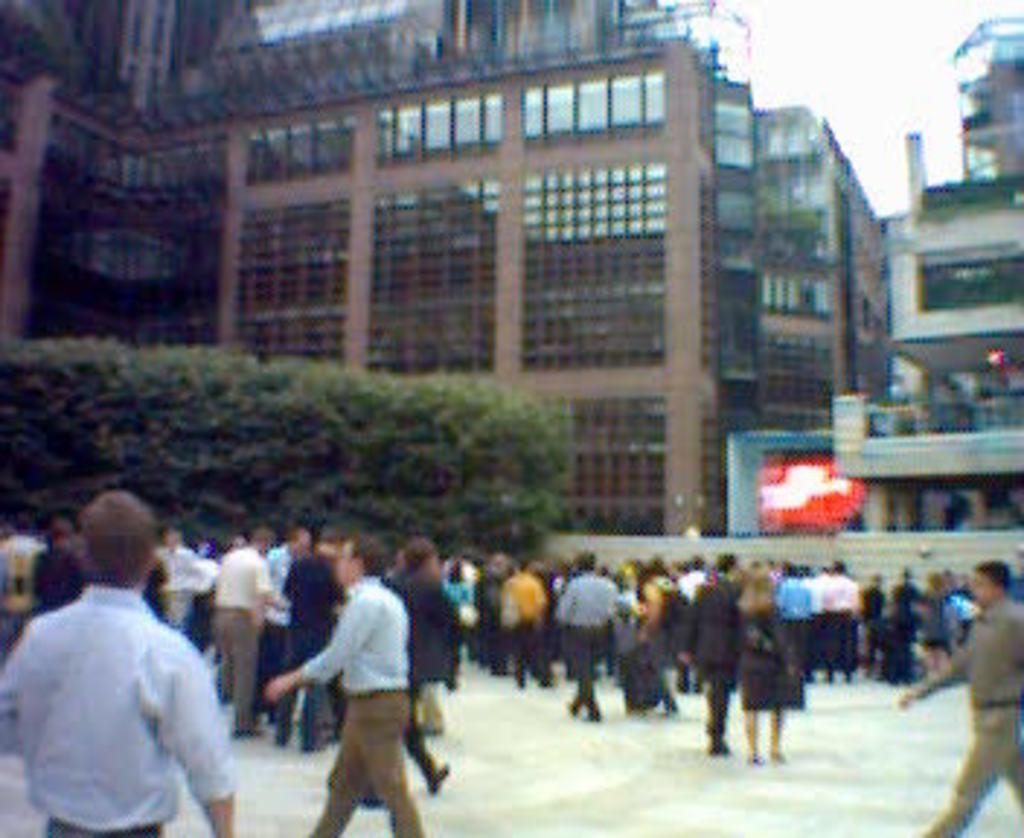Can you describe this image briefly? In this picture we can see some people are standing and some people are walking, in the background there are buildings, on the left side we can see trees, it looks like a screen in the background, there is the sky at the top of the picture. 